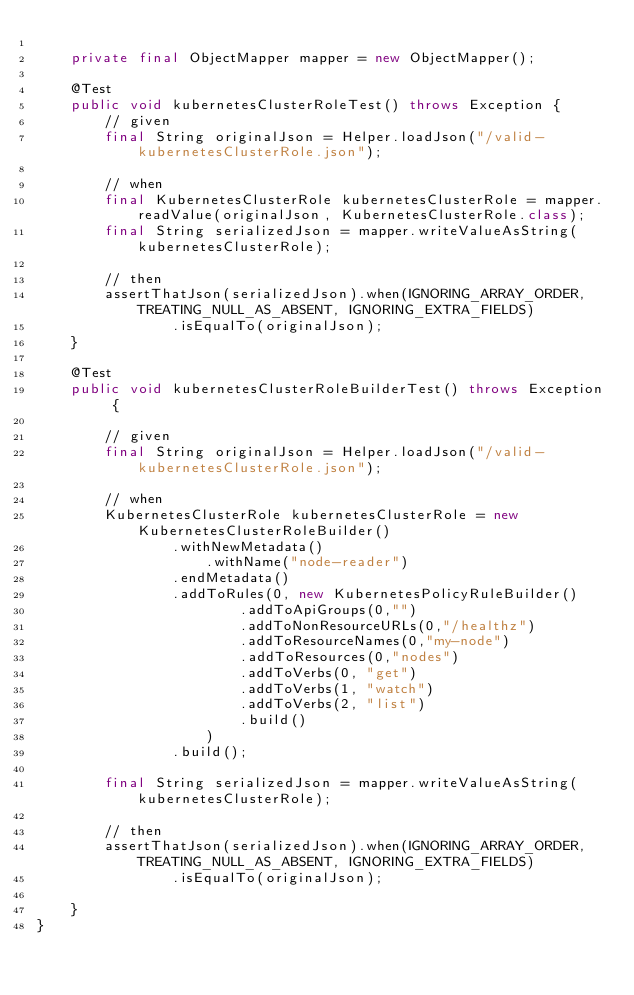Convert code to text. <code><loc_0><loc_0><loc_500><loc_500><_Java_>
    private final ObjectMapper mapper = new ObjectMapper();

    @Test
    public void kubernetesClusterRoleTest() throws Exception {
        // given
        final String originalJson = Helper.loadJson("/valid-kubernetesClusterRole.json");

        // when
        final KubernetesClusterRole kubernetesClusterRole = mapper.readValue(originalJson, KubernetesClusterRole.class);
        final String serializedJson = mapper.writeValueAsString(kubernetesClusterRole);

        // then
        assertThatJson(serializedJson).when(IGNORING_ARRAY_ORDER, TREATING_NULL_AS_ABSENT, IGNORING_EXTRA_FIELDS)
                .isEqualTo(originalJson);
    }

    @Test
    public void kubernetesClusterRoleBuilderTest() throws Exception {

        // given
        final String originalJson = Helper.loadJson("/valid-kubernetesClusterRole.json");

        // when
        KubernetesClusterRole kubernetesClusterRole = new KubernetesClusterRoleBuilder()
                .withNewMetadata()
                    .withName("node-reader")
                .endMetadata()
                .addToRules(0, new KubernetesPolicyRuleBuilder()
                        .addToApiGroups(0,"")
                        .addToNonResourceURLs(0,"/healthz")
                        .addToResourceNames(0,"my-node")
                        .addToResources(0,"nodes")
                        .addToVerbs(0, "get")
                        .addToVerbs(1, "watch")
                        .addToVerbs(2, "list")
                        .build()
                    )
                .build();

        final String serializedJson = mapper.writeValueAsString(kubernetesClusterRole);

        // then
        assertThatJson(serializedJson).when(IGNORING_ARRAY_ORDER, TREATING_NULL_AS_ABSENT, IGNORING_EXTRA_FIELDS)
                .isEqualTo(originalJson);

    }
}
</code> 